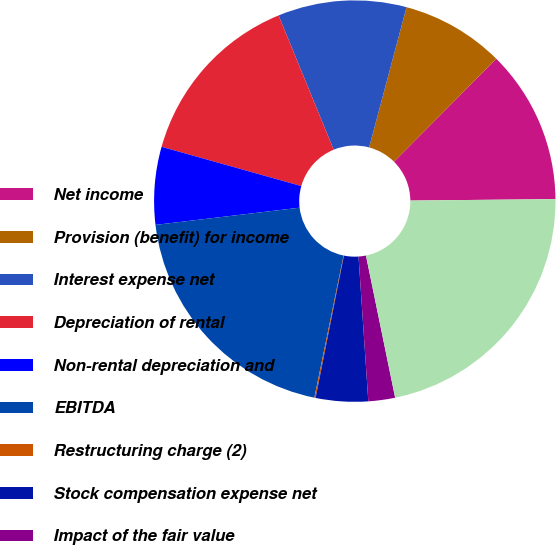Convert chart to OTSL. <chart><loc_0><loc_0><loc_500><loc_500><pie_chart><fcel>Net income<fcel>Provision (benefit) for income<fcel>Interest expense net<fcel>Depreciation of rental<fcel>Non-rental depreciation and<fcel>EBITDA<fcel>Restructuring charge (2)<fcel>Stock compensation expense net<fcel>Impact of the fair value<fcel>Adjusted EBITDA<nl><fcel>12.39%<fcel>8.3%<fcel>10.35%<fcel>14.44%<fcel>6.25%<fcel>19.88%<fcel>0.1%<fcel>4.2%<fcel>2.15%<fcel>21.93%<nl></chart> 